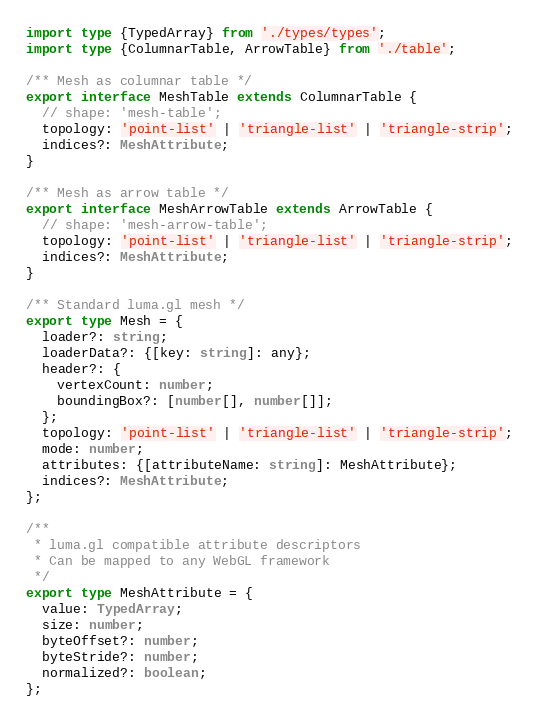<code> <loc_0><loc_0><loc_500><loc_500><_TypeScript_>import type {TypedArray} from './types/types';
import type {ColumnarTable, ArrowTable} from './table';

/** Mesh as columnar table */
export interface MeshTable extends ColumnarTable {
  // shape: 'mesh-table';
  topology: 'point-list' | 'triangle-list' | 'triangle-strip';
  indices?: MeshAttribute;
}

/** Mesh as arrow table */
export interface MeshArrowTable extends ArrowTable {
  // shape: 'mesh-arrow-table';
  topology: 'point-list' | 'triangle-list' | 'triangle-strip';
  indices?: MeshAttribute;
}

/** Standard luma.gl mesh */
export type Mesh = {
  loader?: string;
  loaderData?: {[key: string]: any};
  header?: {
    vertexCount: number;
    boundingBox?: [number[], number[]];
  };
  topology: 'point-list' | 'triangle-list' | 'triangle-strip';
  mode: number;
  attributes: {[attributeName: string]: MeshAttribute};
  indices?: MeshAttribute;
};

/**
 * luma.gl compatible attribute descriptors
 * Can be mapped to any WebGL framework
 */
export type MeshAttribute = {
  value: TypedArray;
  size: number;
  byteOffset?: number;
  byteStride?: number;
  normalized?: boolean;
};
</code> 